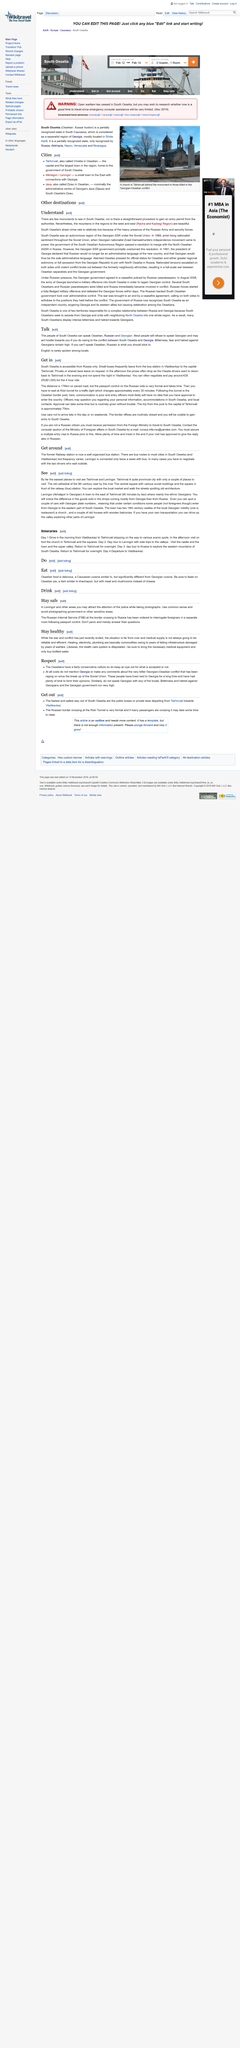Point out several critical features in this image. South Ossetia's street crime is relatively low due to the significant presence of the Russian Army and security forces. There is a bus station in Vladikavkaz from which buses depart to reach the capital Tskhinvali. The bus runs to Leningor only twice a week. The article provides a detailed description of food. According to the article "Other Destinations," there are few monuments to see in South Ossetia. 